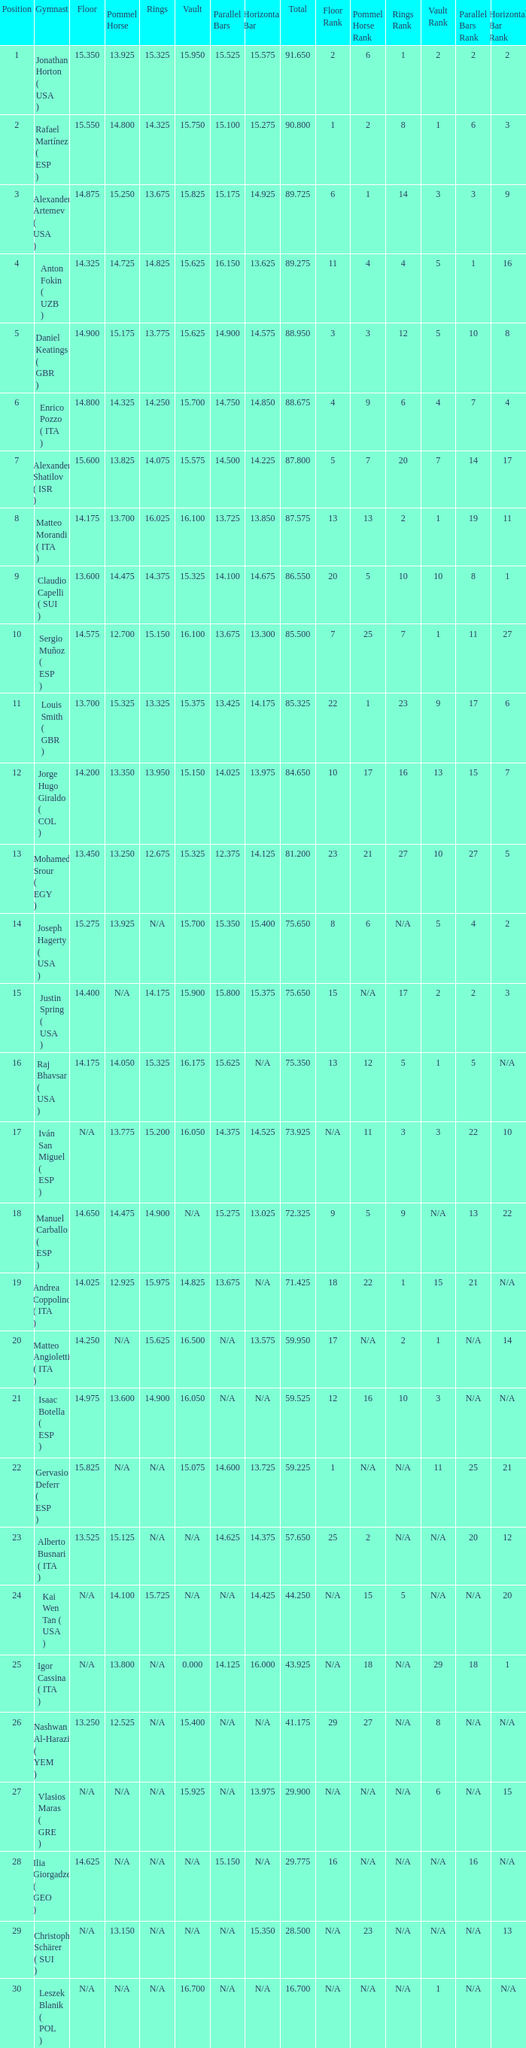If the parallel bars is 16.150, who is the gymnast? Anton Fokin ( UZB ). 